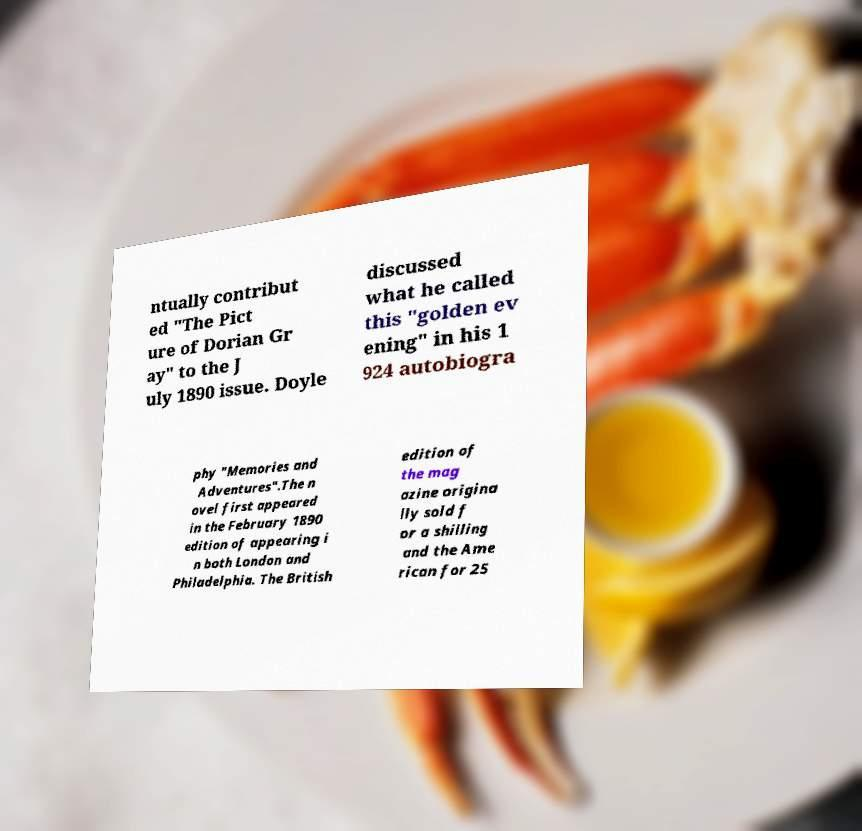There's text embedded in this image that I need extracted. Can you transcribe it verbatim? ntually contribut ed "The Pict ure of Dorian Gr ay" to the J uly 1890 issue. Doyle discussed what he called this "golden ev ening" in his 1 924 autobiogra phy "Memories and Adventures".The n ovel first appeared in the February 1890 edition of appearing i n both London and Philadelphia. The British edition of the mag azine origina lly sold f or a shilling and the Ame rican for 25 